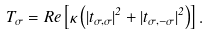Convert formula to latex. <formula><loc_0><loc_0><loc_500><loc_500>T _ { \sigma } = R e \left [ \kappa \left ( | t _ { \sigma , \sigma } | ^ { 2 } + | t _ { \sigma , - \sigma } | ^ { 2 } \right ) \right ] .</formula> 